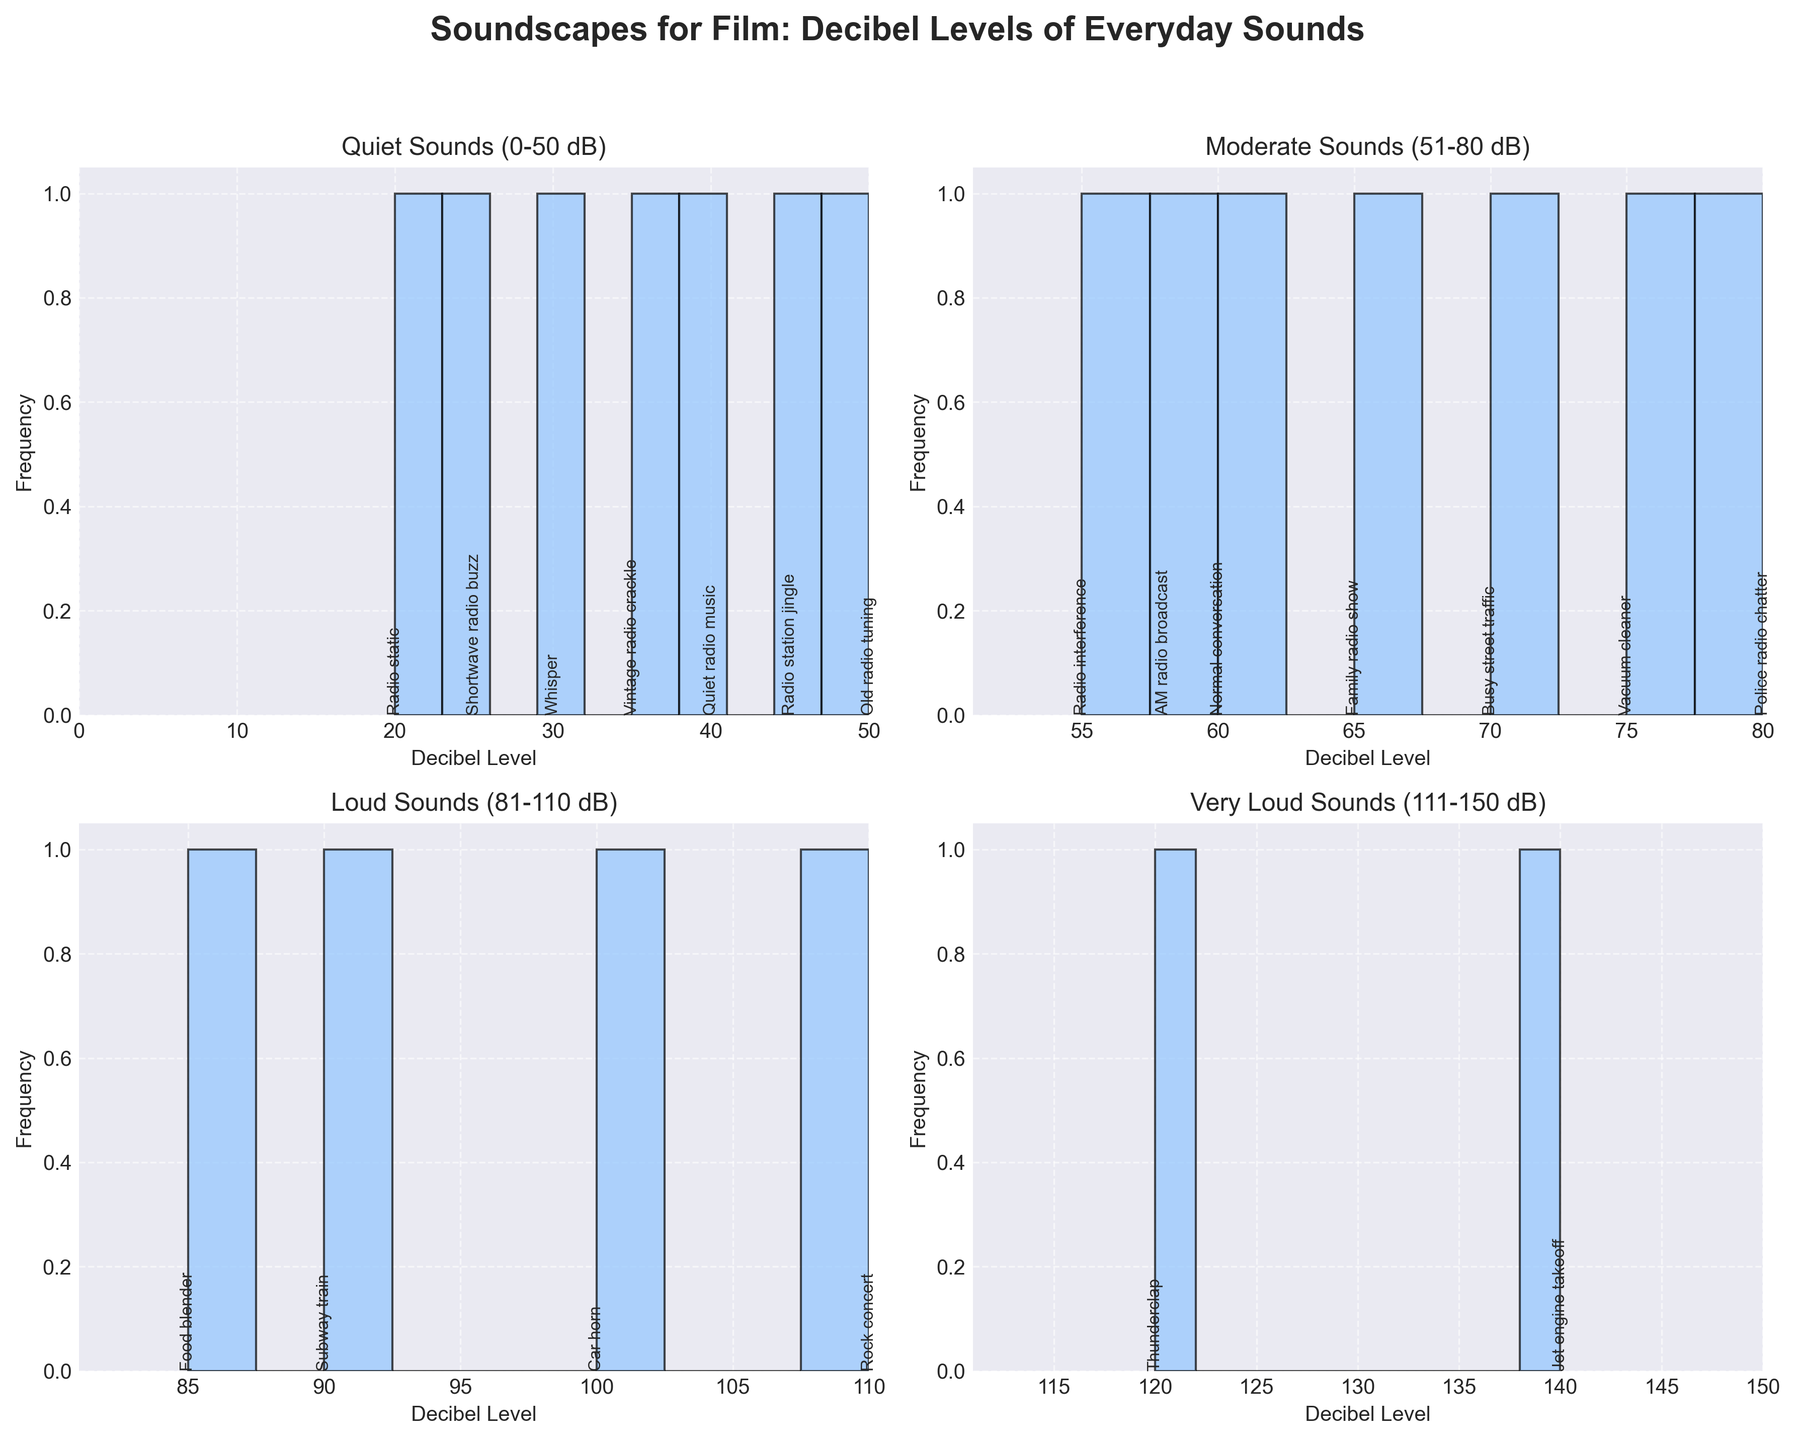1. What is the title of the overall figure? The title is typically displayed at the top of the figure, summarizing the content of all the subplots.
Answer: "Soundscapes for Film: Decibel Levels of Everyday Sounds" 2. In which decibel range (subplots) does "Vintage radio crackle" fall? Look for "Vintage radio crackle" annotations in each subplot to find the corresponding range. It is found in the "Quiet" sounds subplot ranging from 0-50 dB.
Answer: Quiet (0-50 dB) 3. How many unique sounds fall within the "Moderate" sounds range (51-80 dB)? Count the annotations in the "Moderate" sounds subplot which ranges from 51-80 dB.
Answer: 8 sounds 4. What is the minimum decibel level in the "Loud" sounds subplot? Identify the left-most bar (lowest value) in the "Loud" sounds subplot (81-110 dB).
Answer: 85 dB 5. Which sound has the highest decibel level in the "Very Loud" sounds range (111-150 dB)? Look at the annotations in the "Very Loud" sounds subplot (111-150 dB) to find the highest value.
Answer: "Jet engine takeoff" 6. How does the frequency of sounds in the "Quiet" range compare to those in the "Loud" range? Compare the heights of bars (frequencies) in the histograms for the "Quiet" (top-left subplot) and "Loud" (bottom-left subplot) ranges.
Answer: Quiet range has higher frequencies 7. What is the decibel range with the least number of sounds recorded? Compare the number of unique sounds annotated in each subplot to find the subplot with the fewest annotations.
Answer: Very Loud (111-150 dB) 8. Are there more sounds in the "Quiet" or "Moderate" range? Compare the number of annotations in the "Quiet" and "Moderate" subplots.
Answer: Moderate range 9. What is the average decibel level for sounds in the "Very Loud" range? Sum all the decibel levels in the "Very Loud" range and divide by the number of sounds.
Answer: 125 dB [(120+140)/2 = 130] 10. How many of the sounds fall within the 51-60 dB range across all subplots? Count all the sounds in the annotations that fall within the 51-60 dB bracket.
Answer: 3 sounds (AM radio broadcast, Radio interference, Family radio show) 